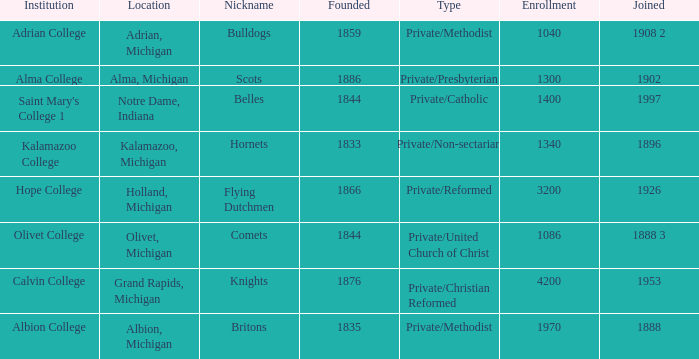Under belles, which is the most possible created? 1844.0. 